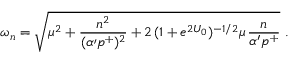Convert formula to latex. <formula><loc_0><loc_0><loc_500><loc_500>\omega _ { n } = \sqrt { \mu ^ { 2 } + { \frac { n ^ { 2 } } { ( \alpha { \prime } p ^ { + } ) ^ { 2 } } } + 2 \, ( 1 + e ^ { 2 U _ { 0 } } ) ^ { - 1 / 2 } \mu \, { \frac { n } { \alpha ^ { \prime } p ^ { + } } } } \ .</formula> 